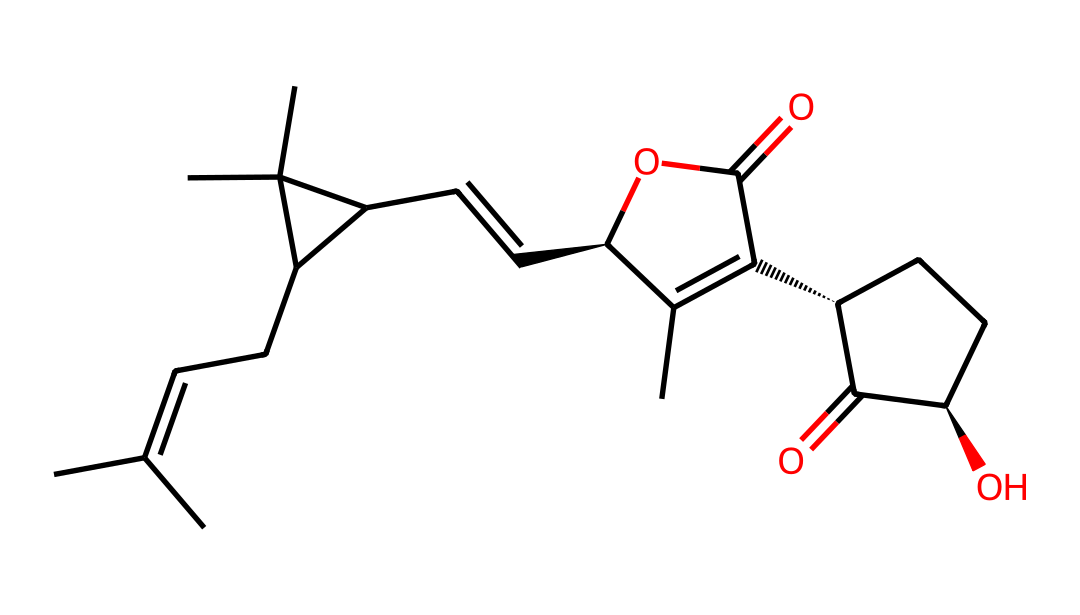What is the primary functional group in this chemical? The structure contains a carboxylic acid group (-COOH) and an ester linkage (-O-), clearly visible in the structure where a carbonyl (C=O) is connected to the hydroxyl (OH) and the ether part. The presence of the -COOH indicates it is a carboxylic acid.
Answer: carboxylic acid How many carbon atoms are in the molecule? To count the carbon atoms, visualize the entire structure. Each vertex and endpoint of the lines in the SMILES representation corresponds to a carbon atom. By strategically counting them, the total comes to sixteen carbon atoms.
Answer: 16 What does the presence of the multiple double bonds indicate? Multiple double bonds in the chemical structure, specifically between carbon-carbon and the carbon-oxygen, indicate unsaturation. Unsaturation often corresponds to increased reactivity and can affect physical properties like boiling point, enhancing the activity of the compound as a pesticide.
Answer: unsaturation What kind of pesticide is represented by this chemical structure? The structure represents a type of organic pesticide known as a pyrethrin, derived from chrysanthemum flowers. Its configuration refers to natural insecticides that are widely used for their effectiveness against pests.
Answer: pyrethrin Which functional groups are characteristic for insecticidal activity in this structure? The structure exhibits both the ester functional group and the cyclic ketone, which are essential for insecticidal properties. The combination of these groups contributes to the mode of action in targeting insect neurological pathways.
Answer: ester and cyclic ketone 